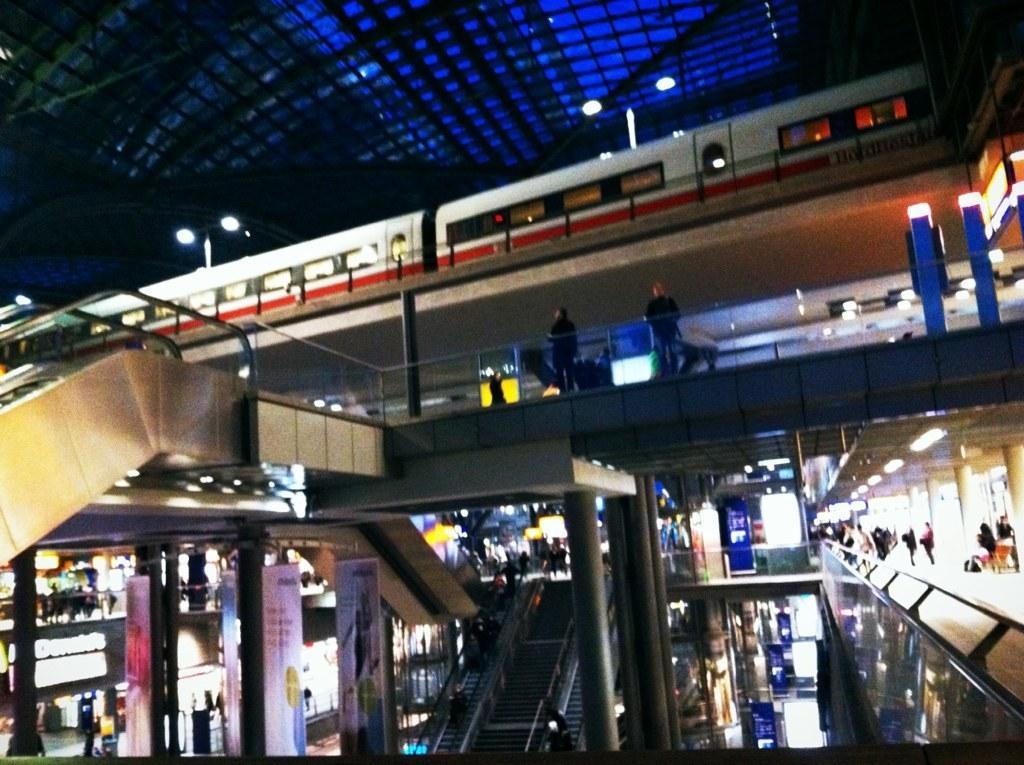Please provide a concise description of this image. This picture shows a train and we see couple of escalators and people standing and we see few lights and banners hanging and few people seated. 